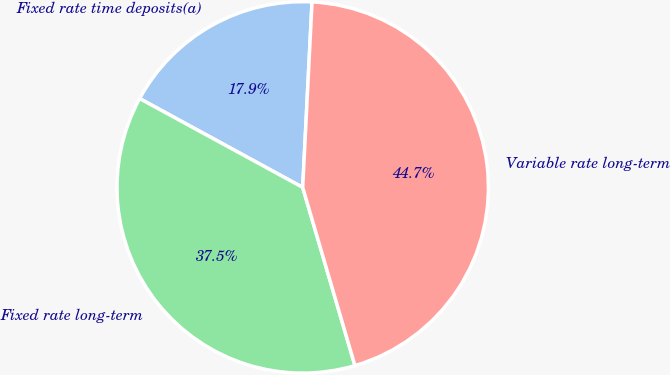Convert chart to OTSL. <chart><loc_0><loc_0><loc_500><loc_500><pie_chart><fcel>Fixed rate time deposits(a)<fcel>Fixed rate long-term<fcel>Variable rate long-term<nl><fcel>17.86%<fcel>37.48%<fcel>44.66%<nl></chart> 